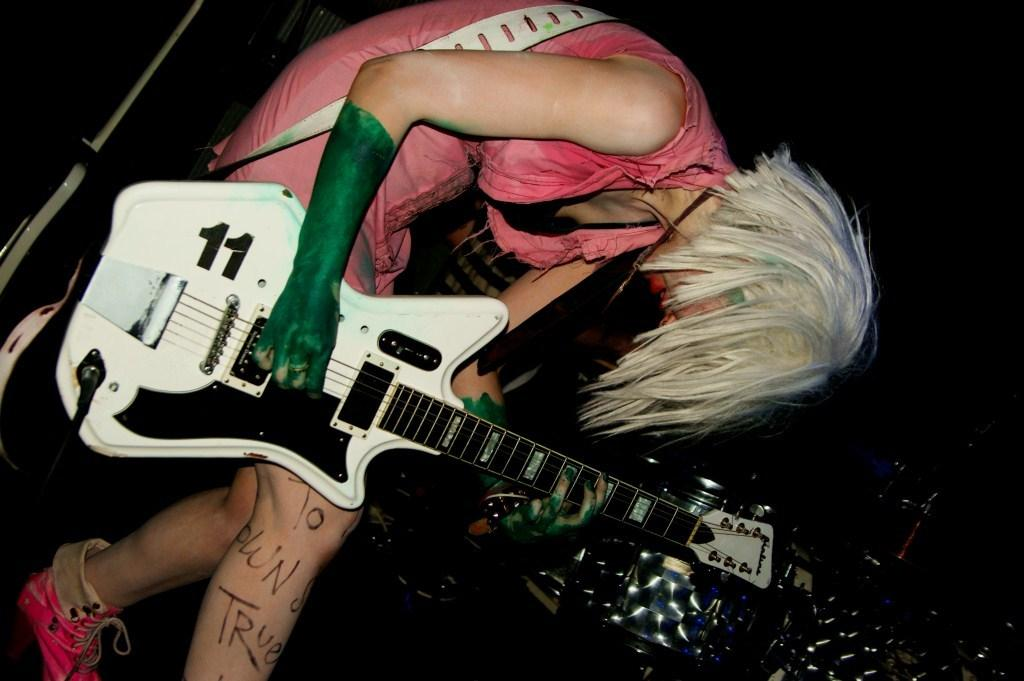Who is the main subject in the image? There is a woman in the image. What is the woman holding in the image? The woman is holding a guitar. What type of glue is the woman using to stick her toes together in the image? There is no glue or toes mentioned in the image; the woman is holding a guitar. 